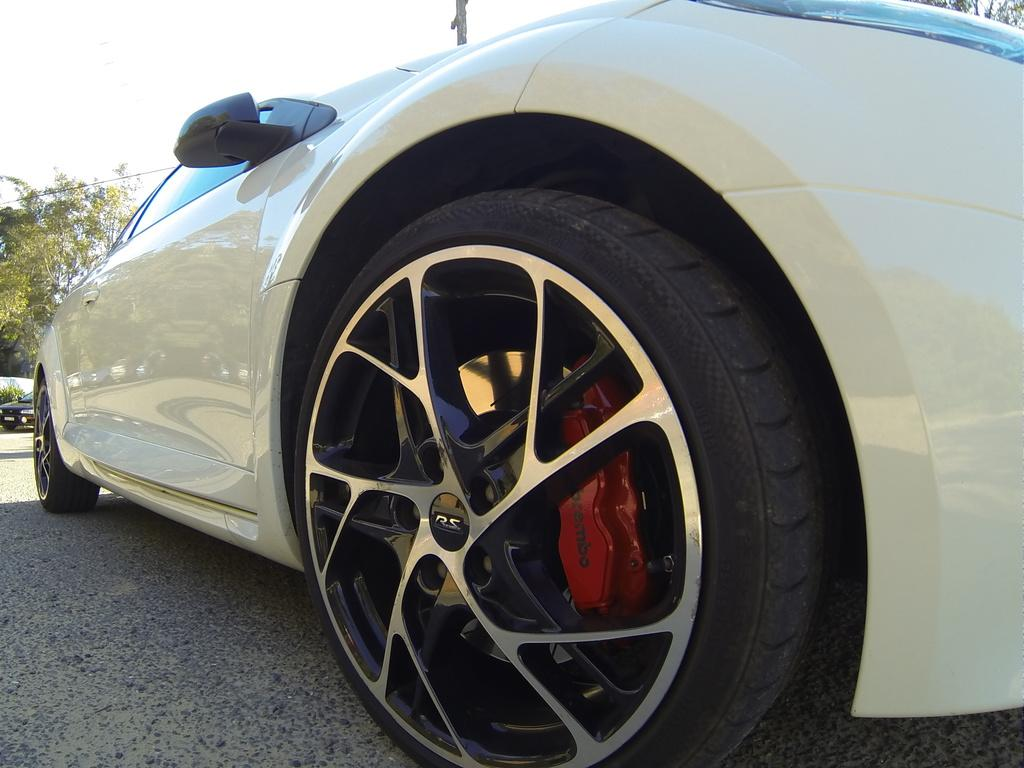What is the main subject in the foreground of the image? There is a car in the foreground of the image. Where is the car located? The car is on the road. Can you describe the background of the image? There is a car in the background of the image, as well as a wall and trees. What type of boat can be seen in the image? There is no boat present in the image. Is there a spy observing the scene in the image? There is no indication of a spy or any surveillance activity in the image. 